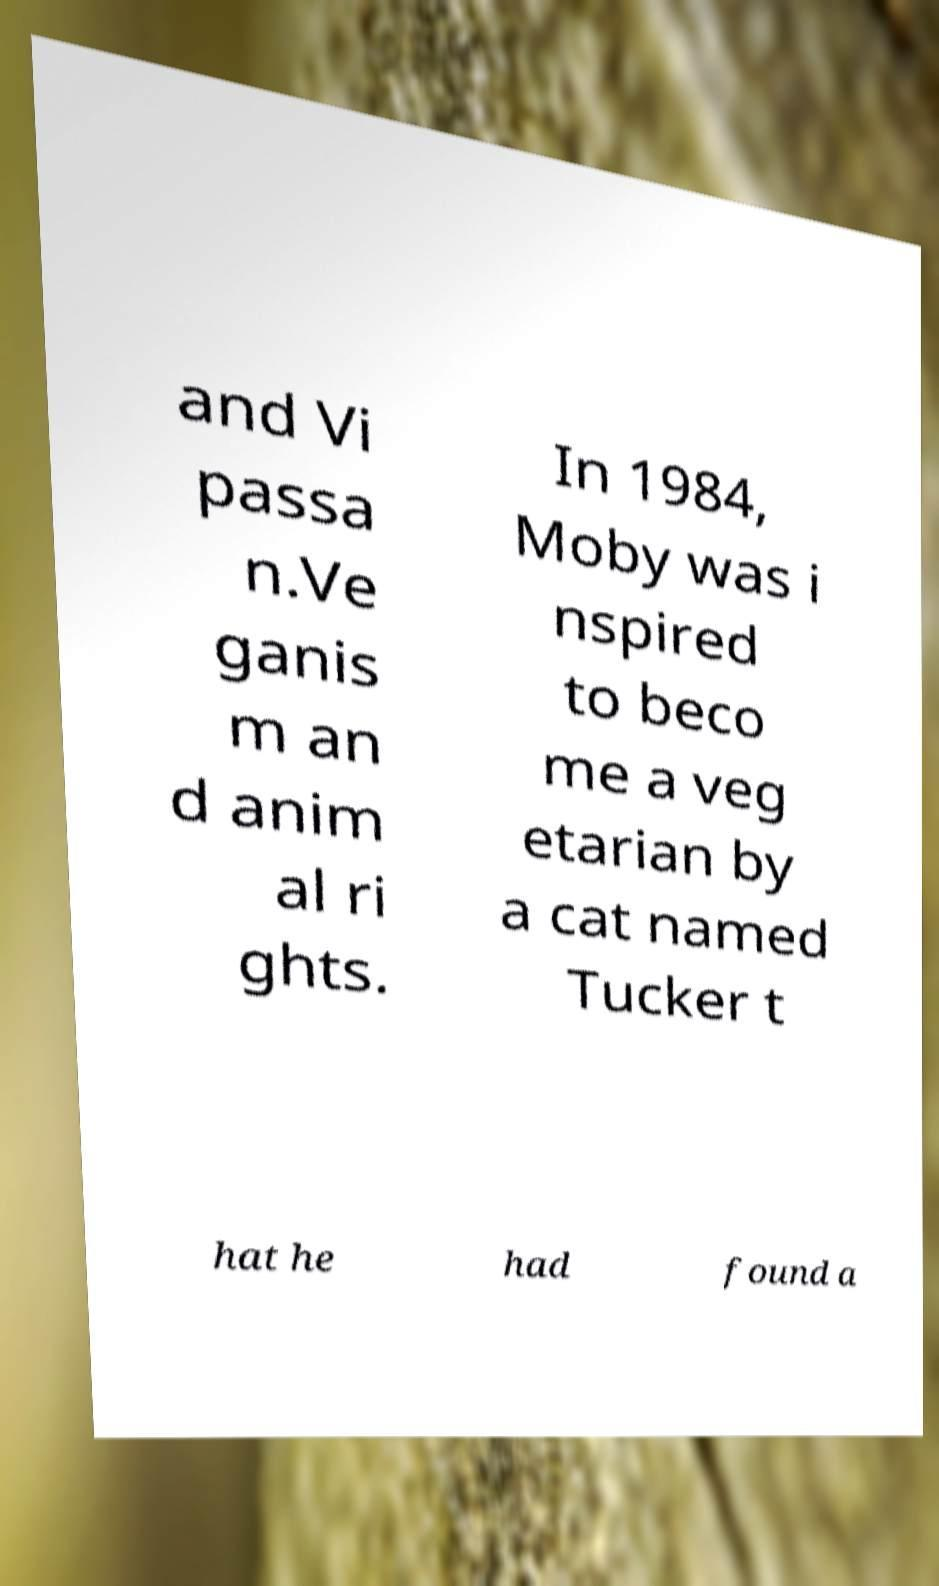For documentation purposes, I need the text within this image transcribed. Could you provide that? and Vi passa n.Ve ganis m an d anim al ri ghts. In 1984, Moby was i nspired to beco me a veg etarian by a cat named Tucker t hat he had found a 